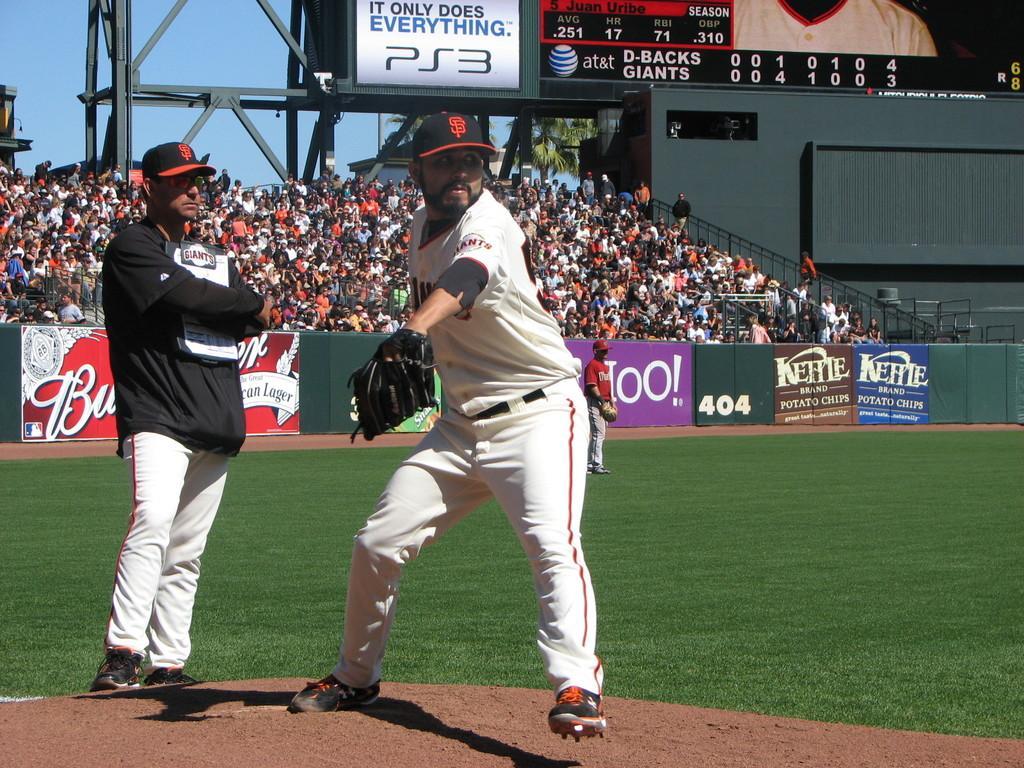Describe this image in one or two sentences. In this image we can see many people in the stadium. There is a digital screen in the image. There is a baseball ground in the image. There is a tree in the image. There is a sky in the image. There are three people on the ground. There are advertising boards in the image. 